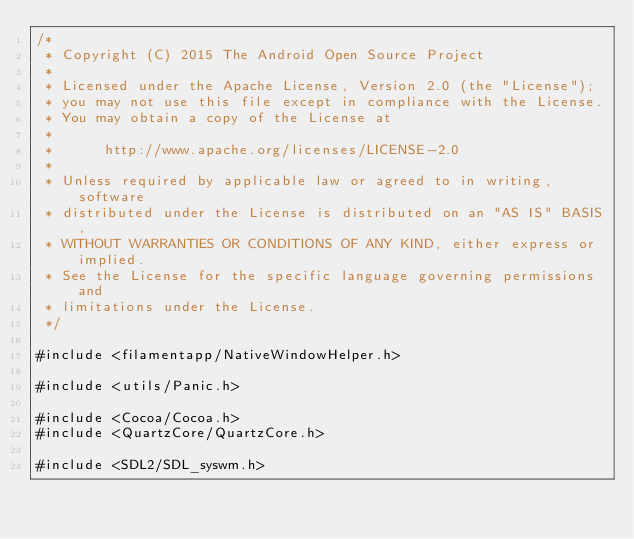<code> <loc_0><loc_0><loc_500><loc_500><_ObjectiveC_>/*
 * Copyright (C) 2015 The Android Open Source Project
 *
 * Licensed under the Apache License, Version 2.0 (the "License");
 * you may not use this file except in compliance with the License.
 * You may obtain a copy of the License at
 *
 *      http://www.apache.org/licenses/LICENSE-2.0
 *
 * Unless required by applicable law or agreed to in writing, software
 * distributed under the License is distributed on an "AS IS" BASIS,
 * WITHOUT WARRANTIES OR CONDITIONS OF ANY KIND, either express or implied.
 * See the License for the specific language governing permissions and
 * limitations under the License.
 */

#include <filamentapp/NativeWindowHelper.h>

#include <utils/Panic.h>

#include <Cocoa/Cocoa.h>
#include <QuartzCore/QuartzCore.h>

#include <SDL2/SDL_syswm.h>
</code> 